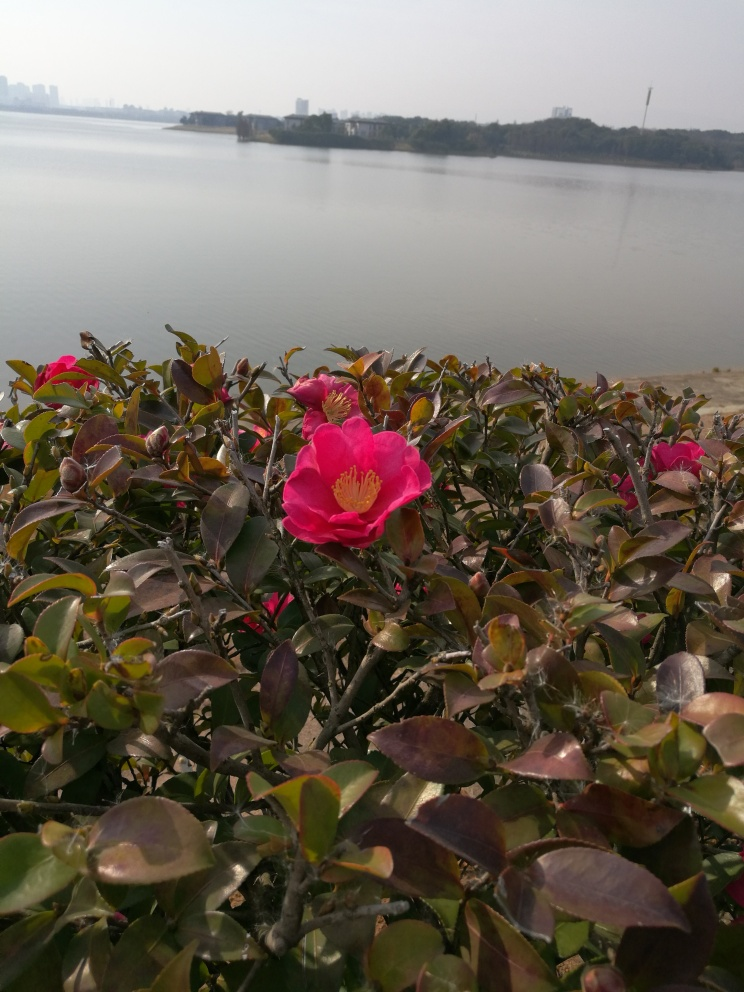How does the lighting affect the appearance of the flowers? The lighting in the image is soft and diffused, perhaps indicating an overcast sky or a time when the sun is not at its peak intensity. This type of lighting helps to evenly illuminate the flowers, reducing harsh shadows and allowing the details of the flower's texture and color gradations to be clearly visible without being washed out by too much brightness. 